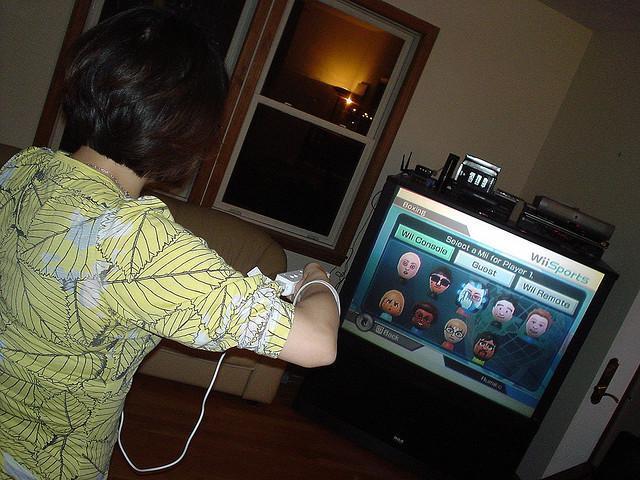How many donuts have chocolate frosting?
Give a very brief answer. 0. 